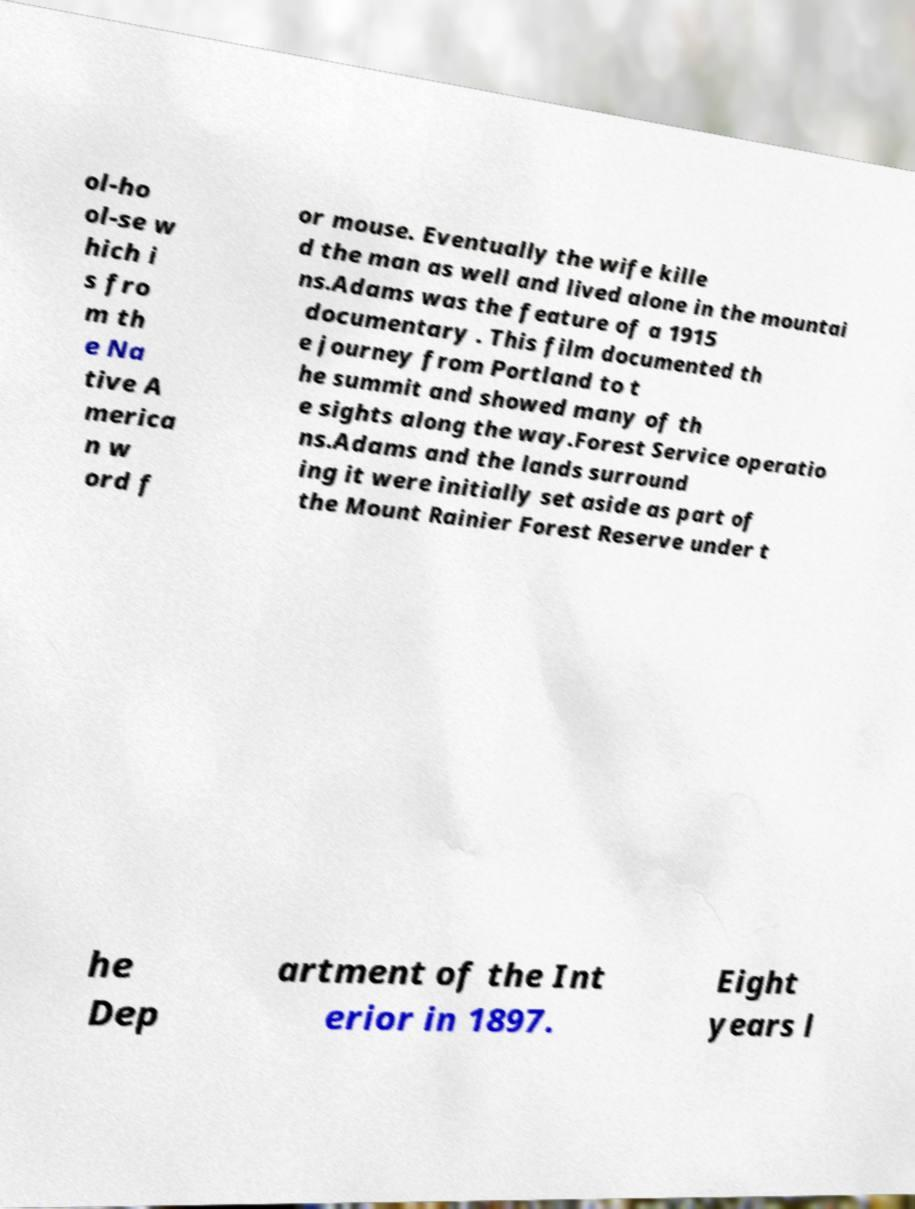Could you assist in decoding the text presented in this image and type it out clearly? ol-ho ol-se w hich i s fro m th e Na tive A merica n w ord f or mouse. Eventually the wife kille d the man as well and lived alone in the mountai ns.Adams was the feature of a 1915 documentary . This film documented th e journey from Portland to t he summit and showed many of th e sights along the way.Forest Service operatio ns.Adams and the lands surround ing it were initially set aside as part of the Mount Rainier Forest Reserve under t he Dep artment of the Int erior in 1897. Eight years l 